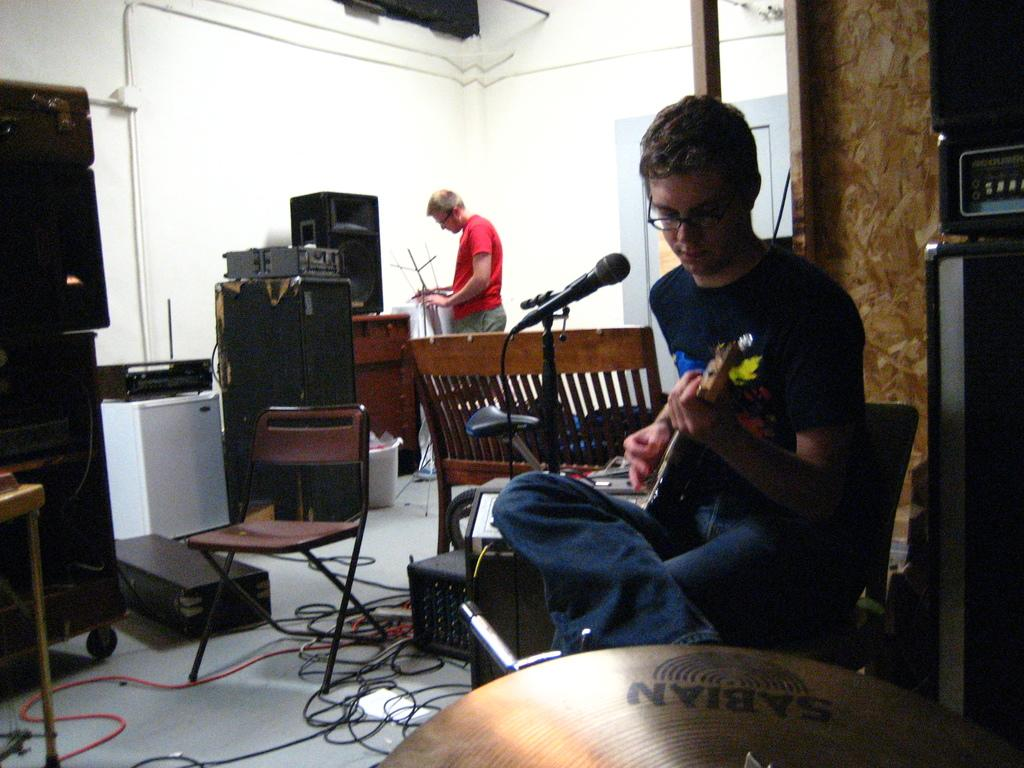Who is the person in the image? There is a man in the image. What is the man doing in the image? The man is playing the guitar. What is the color of the chair the man is sitting on? The man is sitting in a red color chair. What type of lettuce is growing on the ground in the image? There is no lettuce or ground present in the image; it features a man sitting in a red chair and playing the guitar. 